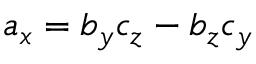<formula> <loc_0><loc_0><loc_500><loc_500>a _ { x } = b _ { y } c _ { z } - b _ { z } c _ { y }</formula> 